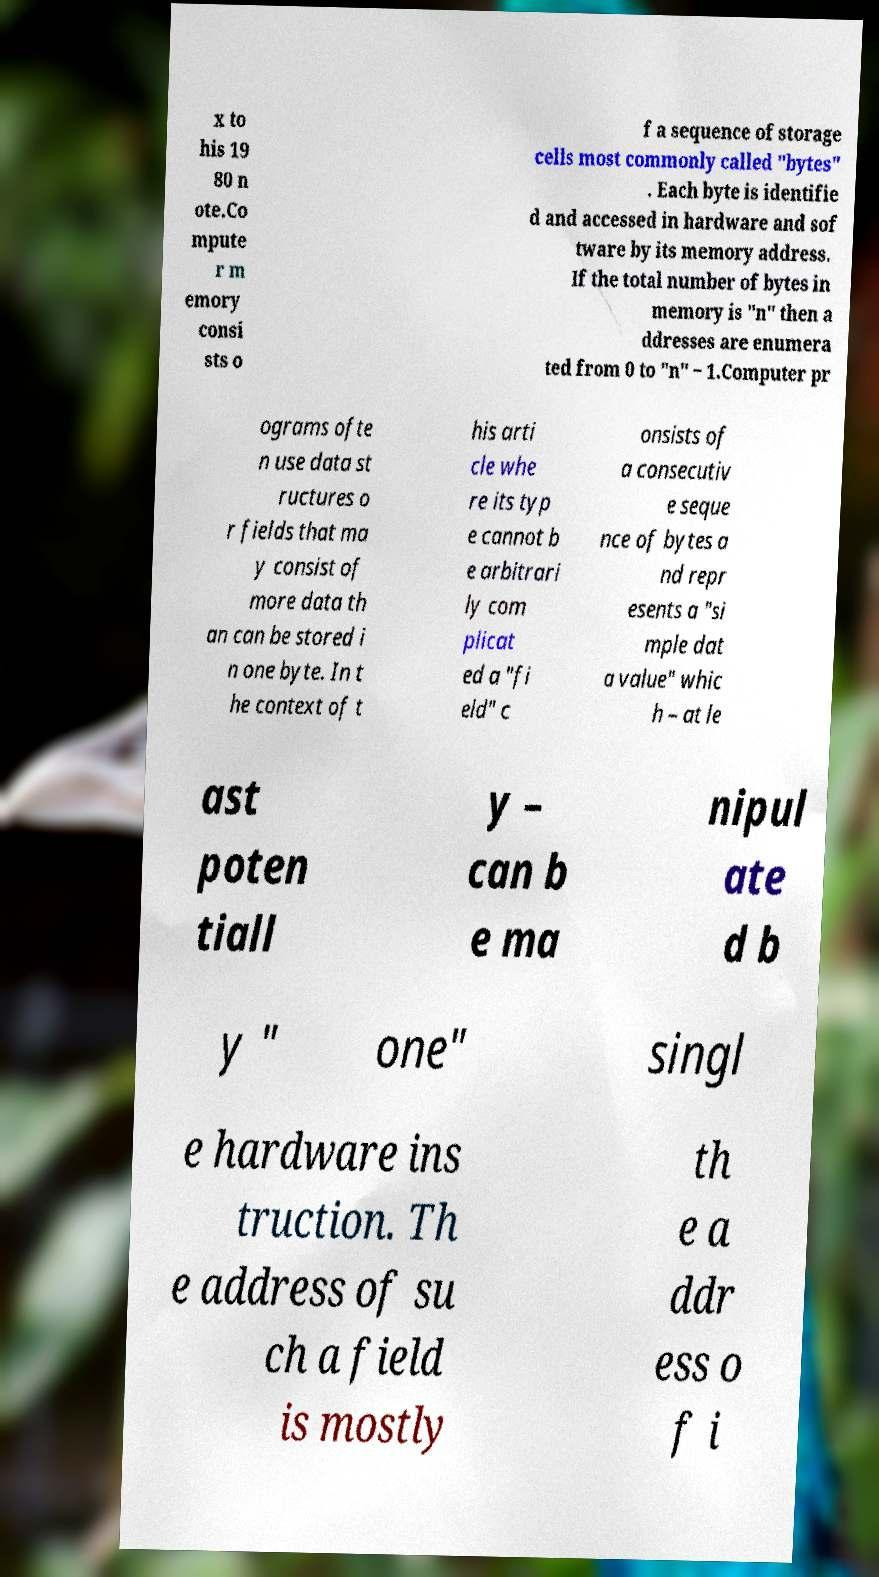What messages or text are displayed in this image? I need them in a readable, typed format. x to his 19 80 n ote.Co mpute r m emory consi sts o f a sequence of storage cells most commonly called "bytes" . Each byte is identifie d and accessed in hardware and sof tware by its memory address. If the total number of bytes in memory is "n" then a ddresses are enumera ted from 0 to "n" − 1.Computer pr ograms ofte n use data st ructures o r fields that ma y consist of more data th an can be stored i n one byte. In t he context of t his arti cle whe re its typ e cannot b e arbitrari ly com plicat ed a "fi eld" c onsists of a consecutiv e seque nce of bytes a nd repr esents a "si mple dat a value" whic h – at le ast poten tiall y – can b e ma nipul ate d b y " one" singl e hardware ins truction. Th e address of su ch a field is mostly th e a ddr ess o f i 